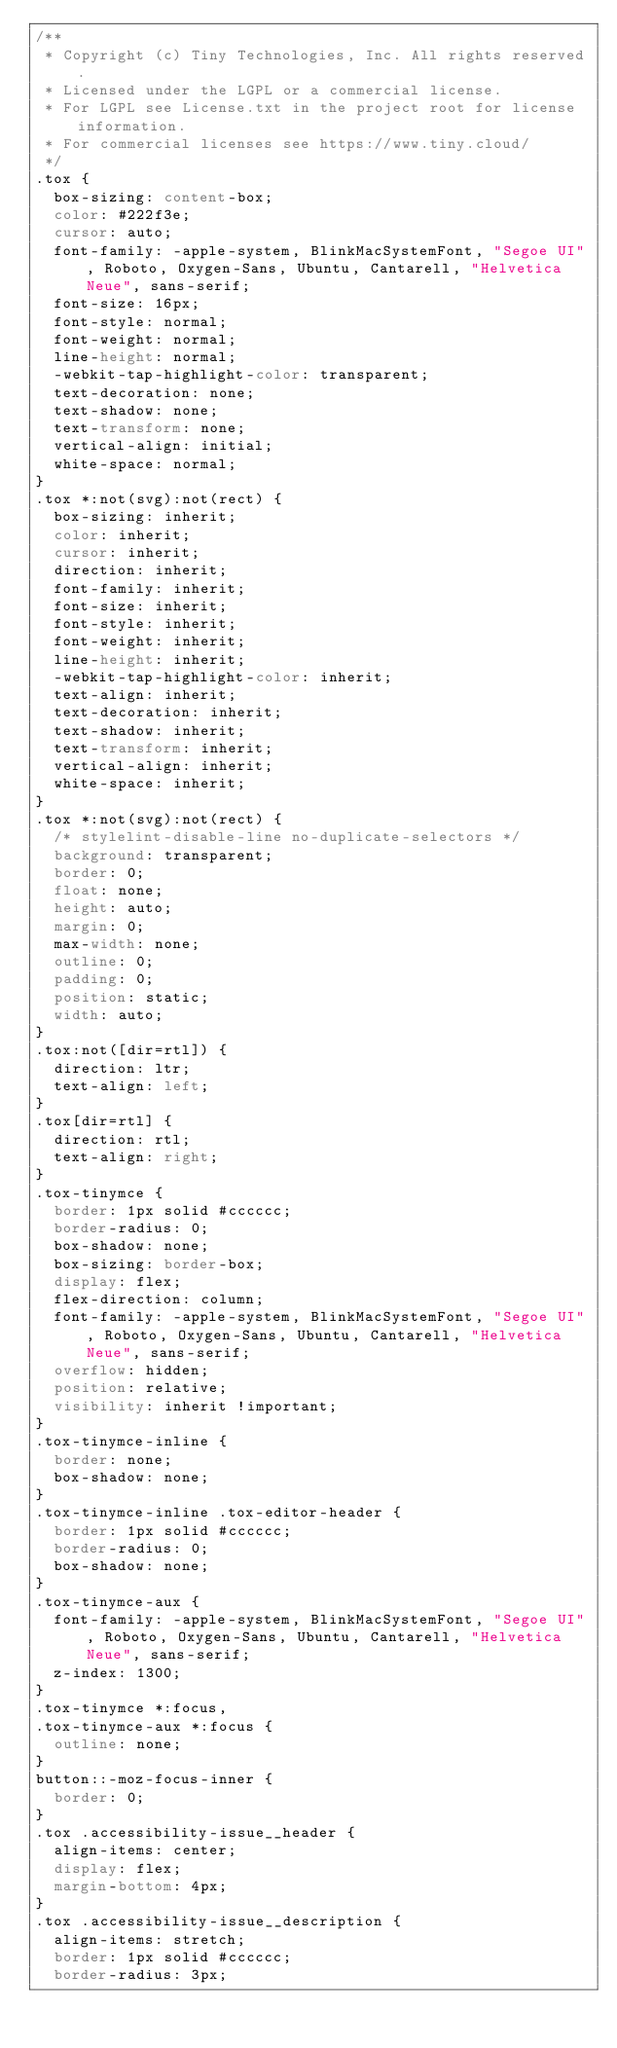Convert code to text. <code><loc_0><loc_0><loc_500><loc_500><_CSS_>/**
 * Copyright (c) Tiny Technologies, Inc. All rights reserved.
 * Licensed under the LGPL or a commercial license.
 * For LGPL see License.txt in the project root for license information.
 * For commercial licenses see https://www.tiny.cloud/
 */
.tox {
  box-sizing: content-box;
  color: #222f3e;
  cursor: auto;
  font-family: -apple-system, BlinkMacSystemFont, "Segoe UI", Roboto, Oxygen-Sans, Ubuntu, Cantarell, "Helvetica Neue", sans-serif;
  font-size: 16px;
  font-style: normal;
  font-weight: normal;
  line-height: normal;
  -webkit-tap-highlight-color: transparent;
  text-decoration: none;
  text-shadow: none;
  text-transform: none;
  vertical-align: initial;
  white-space: normal;
}
.tox *:not(svg):not(rect) {
  box-sizing: inherit;
  color: inherit;
  cursor: inherit;
  direction: inherit;
  font-family: inherit;
  font-size: inherit;
  font-style: inherit;
  font-weight: inherit;
  line-height: inherit;
  -webkit-tap-highlight-color: inherit;
  text-align: inherit;
  text-decoration: inherit;
  text-shadow: inherit;
  text-transform: inherit;
  vertical-align: inherit;
  white-space: inherit;
}
.tox *:not(svg):not(rect) {
  /* stylelint-disable-line no-duplicate-selectors */
  background: transparent;
  border: 0;
  float: none;
  height: auto;
  margin: 0;
  max-width: none;
  outline: 0;
  padding: 0;
  position: static;
  width: auto;
}
.tox:not([dir=rtl]) {
  direction: ltr;
  text-align: left;
}
.tox[dir=rtl] {
  direction: rtl;
  text-align: right;
}
.tox-tinymce {
  border: 1px solid #cccccc;
  border-radius: 0;
  box-shadow: none;
  box-sizing: border-box;
  display: flex;
  flex-direction: column;
  font-family: -apple-system, BlinkMacSystemFont, "Segoe UI", Roboto, Oxygen-Sans, Ubuntu, Cantarell, "Helvetica Neue", sans-serif;
  overflow: hidden;
  position: relative;
  visibility: inherit !important;
}
.tox-tinymce-inline {
  border: none;
  box-shadow: none;
}
.tox-tinymce-inline .tox-editor-header {
  border: 1px solid #cccccc;
  border-radius: 0;
  box-shadow: none;
}
.tox-tinymce-aux {
  font-family: -apple-system, BlinkMacSystemFont, "Segoe UI", Roboto, Oxygen-Sans, Ubuntu, Cantarell, "Helvetica Neue", sans-serif;
  z-index: 1300;
}
.tox-tinymce *:focus,
.tox-tinymce-aux *:focus {
  outline: none;
}
button::-moz-focus-inner {
  border: 0;
}
.tox .accessibility-issue__header {
  align-items: center;
  display: flex;
  margin-bottom: 4px;
}
.tox .accessibility-issue__description {
  align-items: stretch;
  border: 1px solid #cccccc;
  border-radius: 3px;</code> 